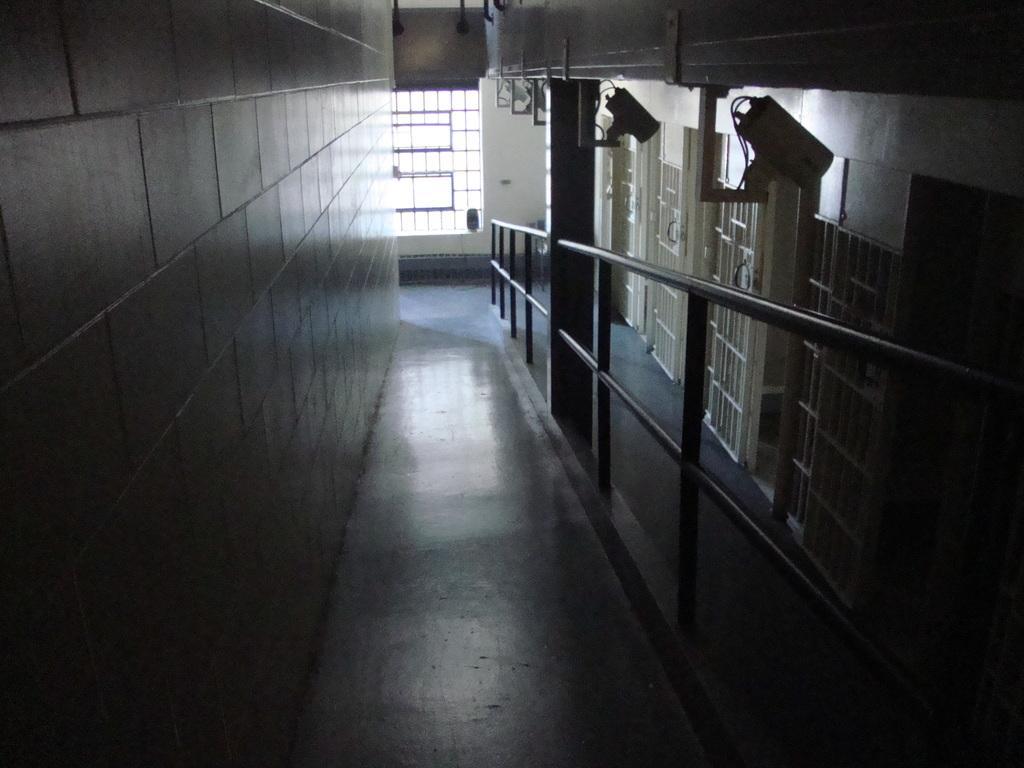Describe this image in one or two sentences. This is an inside view. At the bottom, I can see the floor. On the right side there is a railing and there are few windows to the wall. At the top of the image there are few black color objects which seem to be cameras. On the left side there is a wall. In the background there is a window. 